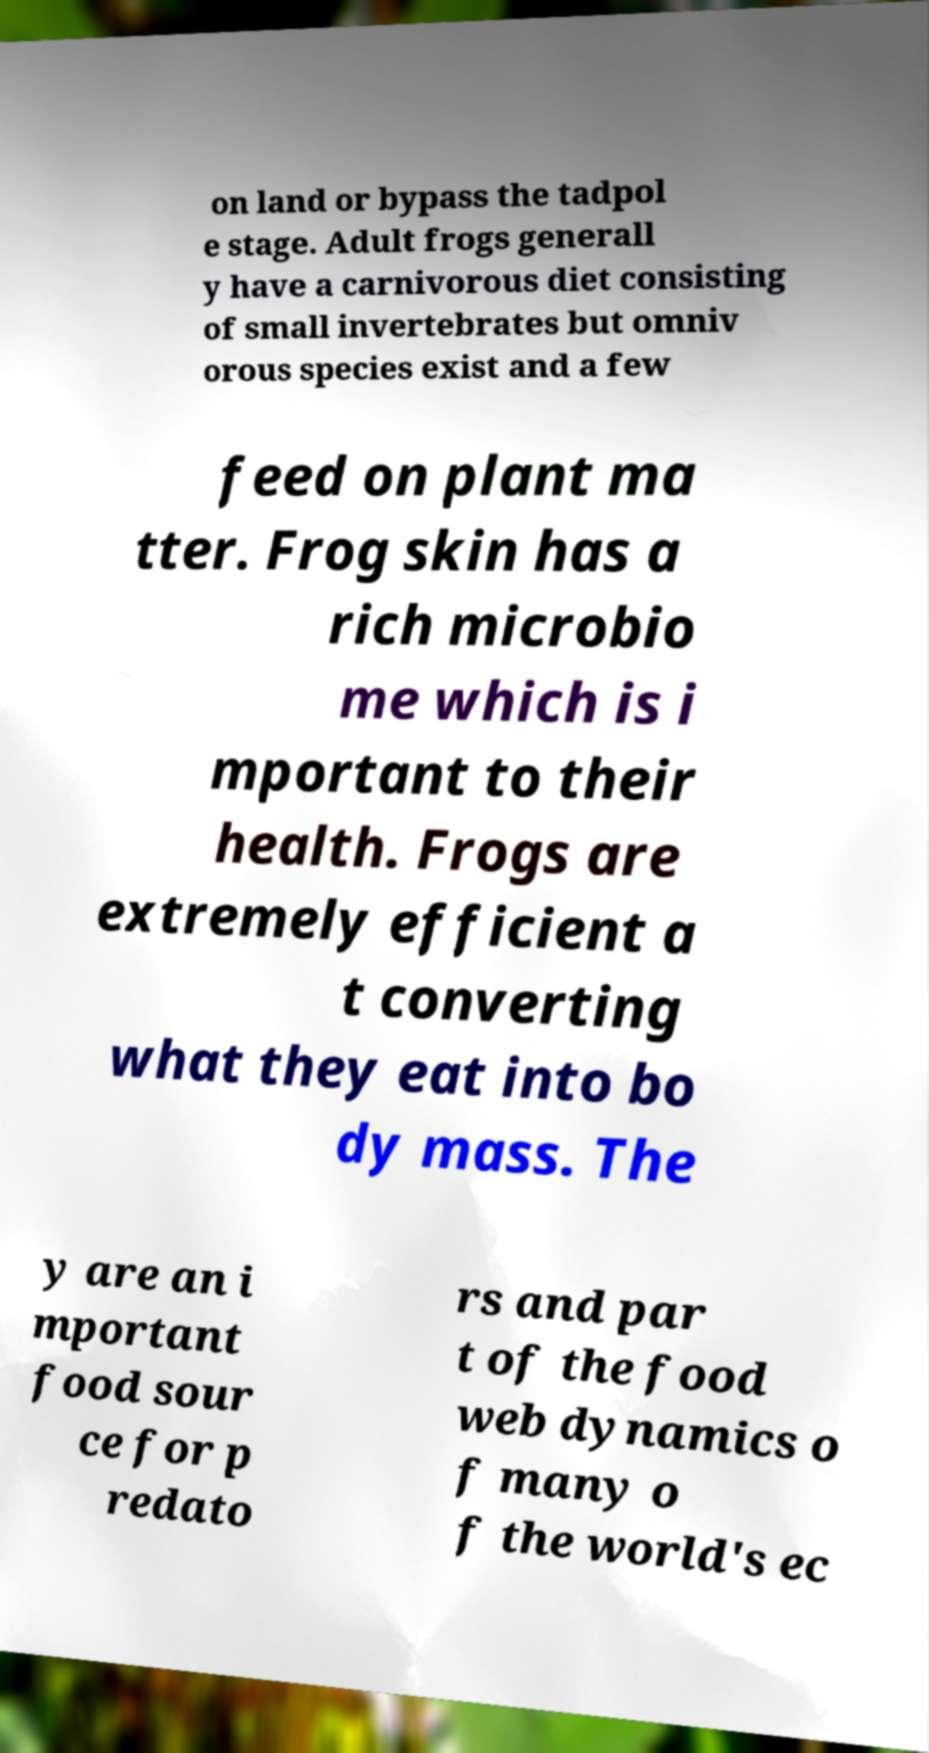I need the written content from this picture converted into text. Can you do that? on land or bypass the tadpol e stage. Adult frogs generall y have a carnivorous diet consisting of small invertebrates but omniv orous species exist and a few feed on plant ma tter. Frog skin has a rich microbio me which is i mportant to their health. Frogs are extremely efficient a t converting what they eat into bo dy mass. The y are an i mportant food sour ce for p redato rs and par t of the food web dynamics o f many o f the world's ec 